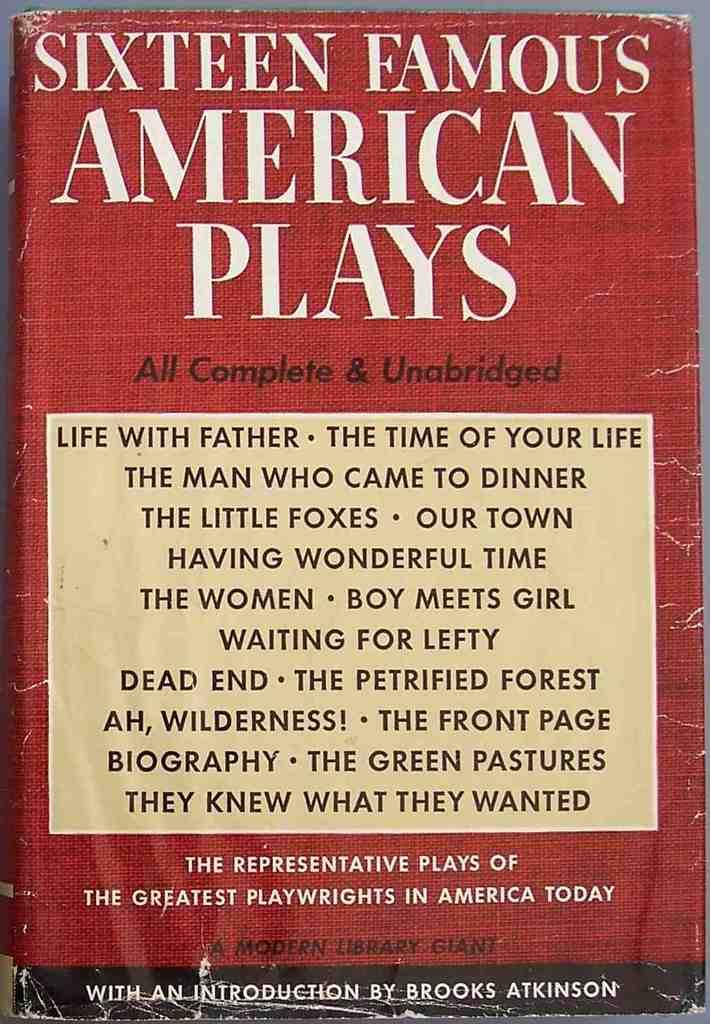What type of object is the main subject of the image? The image is a front view of a textbook. What can be seen on the surface of the textbook? There is text written on the textbook. Can you see any flies or islands in the image? No, there are no flies or islands present in the image; it is a front view of a textbook with text written on it. 